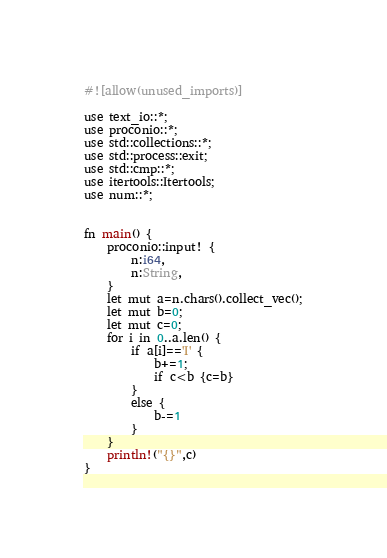Convert code to text. <code><loc_0><loc_0><loc_500><loc_500><_Rust_>#![allow(unused_imports)]

use text_io::*;
use proconio::*;
use std::collections::*;
use std::process::exit;
use std::cmp::*;
use itertools::Itertools;
use num::*;


fn main() {
    proconio::input! {
        n:i64,
        n:String,
    }
    let mut a=n.chars().collect_vec();
    let mut b=0;
    let mut c=0;
    for i in 0..a.len() {
        if a[i]=='I' {
            b+=1;
            if c<b {c=b}
        }
        else {
            b-=1
        }
    }
    println!("{}",c)
}</code> 